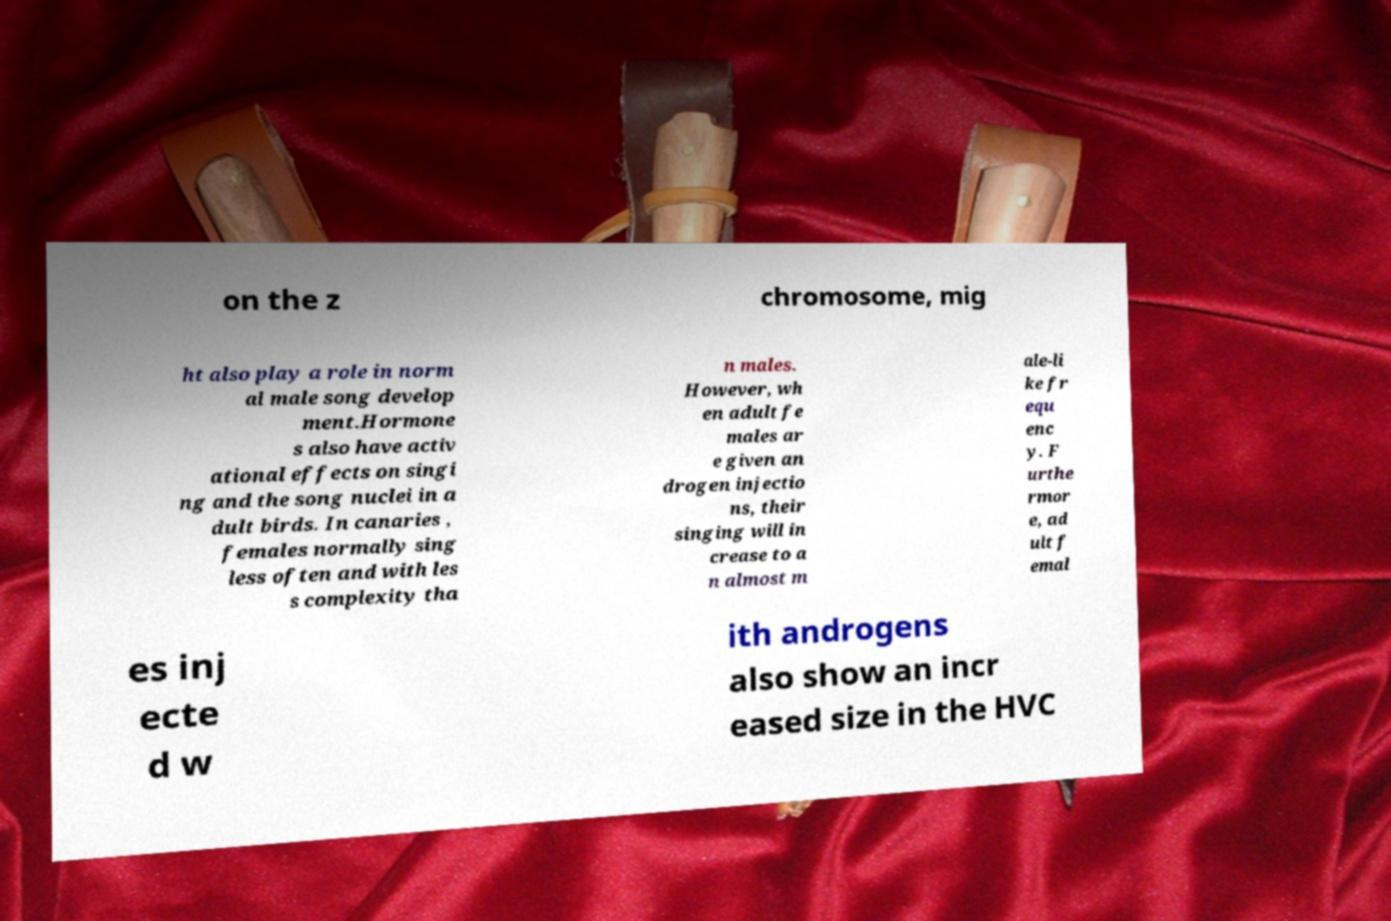Can you accurately transcribe the text from the provided image for me? on the z chromosome, mig ht also play a role in norm al male song develop ment.Hormone s also have activ ational effects on singi ng and the song nuclei in a dult birds. In canaries , females normally sing less often and with les s complexity tha n males. However, wh en adult fe males ar e given an drogen injectio ns, their singing will in crease to a n almost m ale-li ke fr equ enc y. F urthe rmor e, ad ult f emal es inj ecte d w ith androgens also show an incr eased size in the HVC 